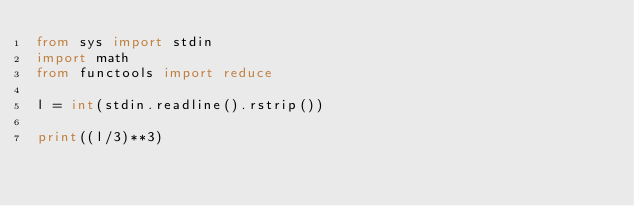<code> <loc_0><loc_0><loc_500><loc_500><_Python_>from sys import stdin
import math
from functools import reduce

l = int(stdin.readline().rstrip())

print((l/3)**3)</code> 